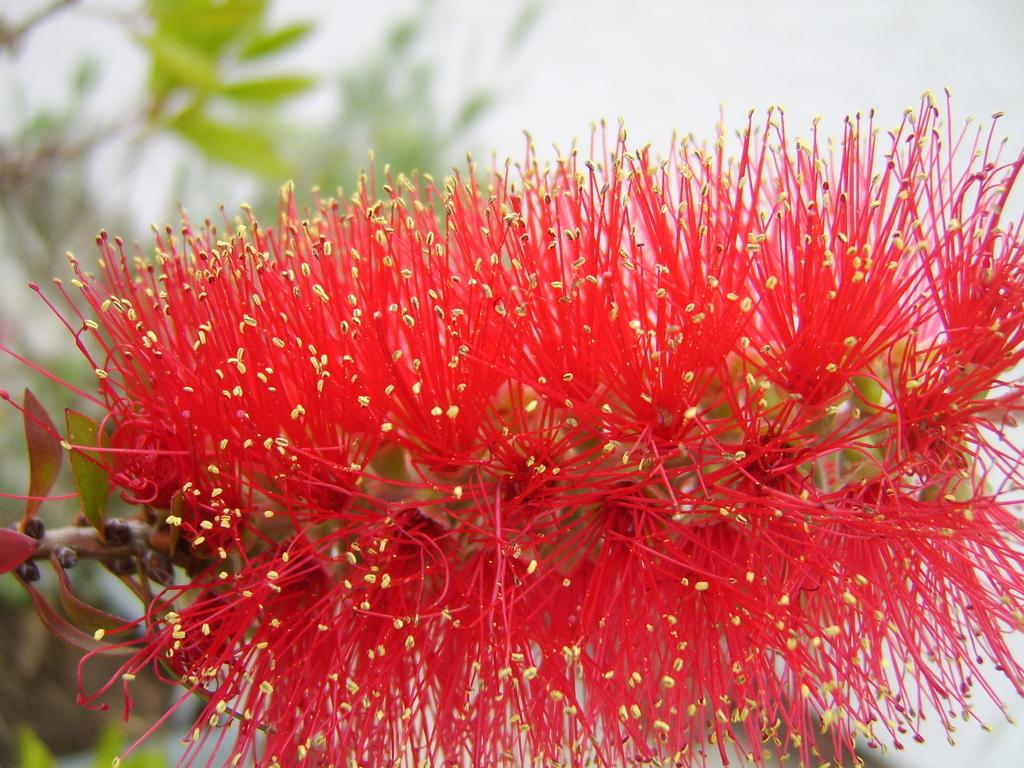What is the main subject of the image? There is a flower in the center of the image. What color is the flower? The flower is red. What else can be seen in the background of the image? There are leaves in the background of the image. What type of quilt is being used to cover the flower in the image? There is no quilt present in the image; it features a red flower with leaves in the background. What part of the flower is being shown in the image? The entire flower is visible in the image, as it is the main subject. 